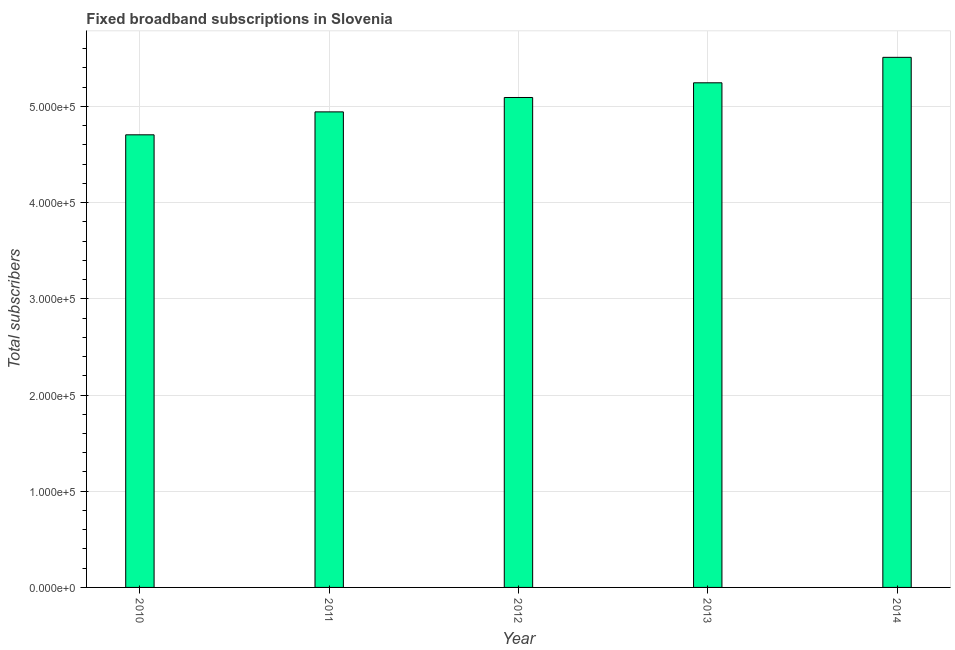Does the graph contain grids?
Your answer should be compact. Yes. What is the title of the graph?
Your response must be concise. Fixed broadband subscriptions in Slovenia. What is the label or title of the X-axis?
Provide a succinct answer. Year. What is the label or title of the Y-axis?
Your answer should be compact. Total subscribers. What is the total number of fixed broadband subscriptions in 2010?
Ensure brevity in your answer.  4.71e+05. Across all years, what is the maximum total number of fixed broadband subscriptions?
Your response must be concise. 5.51e+05. Across all years, what is the minimum total number of fixed broadband subscriptions?
Make the answer very short. 4.71e+05. In which year was the total number of fixed broadband subscriptions maximum?
Your response must be concise. 2014. What is the sum of the total number of fixed broadband subscriptions?
Offer a terse response. 2.55e+06. What is the difference between the total number of fixed broadband subscriptions in 2012 and 2013?
Give a very brief answer. -1.53e+04. What is the average total number of fixed broadband subscriptions per year?
Make the answer very short. 5.10e+05. What is the median total number of fixed broadband subscriptions?
Your answer should be compact. 5.09e+05. Is the total number of fixed broadband subscriptions in 2012 less than that in 2013?
Offer a terse response. Yes. Is the difference between the total number of fixed broadband subscriptions in 2011 and 2014 greater than the difference between any two years?
Provide a short and direct response. No. What is the difference between the highest and the second highest total number of fixed broadband subscriptions?
Give a very brief answer. 2.65e+04. Is the sum of the total number of fixed broadband subscriptions in 2010 and 2013 greater than the maximum total number of fixed broadband subscriptions across all years?
Keep it short and to the point. Yes. What is the difference between the highest and the lowest total number of fixed broadband subscriptions?
Ensure brevity in your answer.  8.06e+04. In how many years, is the total number of fixed broadband subscriptions greater than the average total number of fixed broadband subscriptions taken over all years?
Provide a succinct answer. 2. Are all the bars in the graph horizontal?
Your answer should be very brief. No. What is the difference between two consecutive major ticks on the Y-axis?
Make the answer very short. 1.00e+05. What is the Total subscribers in 2010?
Your answer should be compact. 4.71e+05. What is the Total subscribers of 2011?
Keep it short and to the point. 4.94e+05. What is the Total subscribers of 2012?
Provide a short and direct response. 5.09e+05. What is the Total subscribers of 2013?
Offer a very short reply. 5.25e+05. What is the Total subscribers of 2014?
Ensure brevity in your answer.  5.51e+05. What is the difference between the Total subscribers in 2010 and 2011?
Offer a terse response. -2.38e+04. What is the difference between the Total subscribers in 2010 and 2012?
Your answer should be compact. -3.88e+04. What is the difference between the Total subscribers in 2010 and 2013?
Give a very brief answer. -5.41e+04. What is the difference between the Total subscribers in 2010 and 2014?
Your answer should be compact. -8.06e+04. What is the difference between the Total subscribers in 2011 and 2012?
Offer a terse response. -1.50e+04. What is the difference between the Total subscribers in 2011 and 2013?
Your response must be concise. -3.02e+04. What is the difference between the Total subscribers in 2011 and 2014?
Ensure brevity in your answer.  -5.67e+04. What is the difference between the Total subscribers in 2012 and 2013?
Give a very brief answer. -1.53e+04. What is the difference between the Total subscribers in 2012 and 2014?
Make the answer very short. -4.18e+04. What is the difference between the Total subscribers in 2013 and 2014?
Make the answer very short. -2.65e+04. What is the ratio of the Total subscribers in 2010 to that in 2012?
Provide a short and direct response. 0.92. What is the ratio of the Total subscribers in 2010 to that in 2013?
Your answer should be very brief. 0.9. What is the ratio of the Total subscribers in 2010 to that in 2014?
Give a very brief answer. 0.85. What is the ratio of the Total subscribers in 2011 to that in 2013?
Provide a succinct answer. 0.94. What is the ratio of the Total subscribers in 2011 to that in 2014?
Your answer should be very brief. 0.9. What is the ratio of the Total subscribers in 2012 to that in 2014?
Provide a succinct answer. 0.92. What is the ratio of the Total subscribers in 2013 to that in 2014?
Offer a terse response. 0.95. 